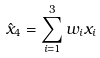Convert formula to latex. <formula><loc_0><loc_0><loc_500><loc_500>\hat { x } _ { 4 } = \sum _ { i = 1 } ^ { 3 } w _ { i } x _ { i }</formula> 